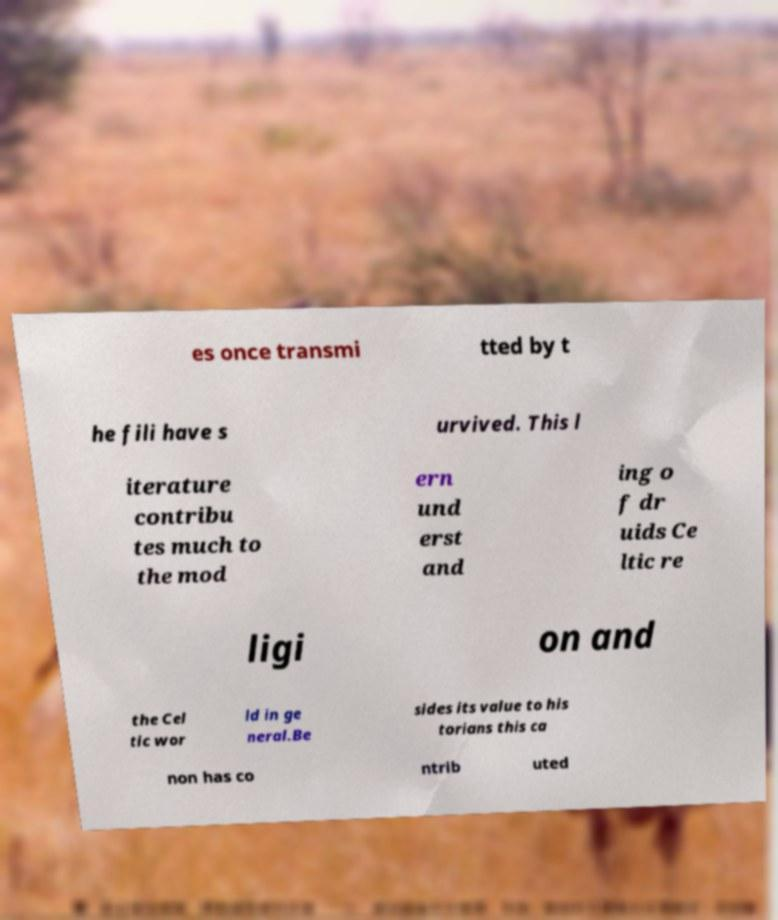Could you extract and type out the text from this image? es once transmi tted by t he fili have s urvived. This l iterature contribu tes much to the mod ern und erst and ing o f dr uids Ce ltic re ligi on and the Cel tic wor ld in ge neral.Be sides its value to his torians this ca non has co ntrib uted 